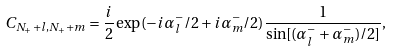Convert formula to latex. <formula><loc_0><loc_0><loc_500><loc_500>C _ { N _ { + } + l , N _ { + } + m } = \frac { i } { 2 } \exp ( - i \alpha _ { l } ^ { - } / 2 + i \alpha _ { m } ^ { - } / 2 ) \frac { 1 } { \sin [ ( \alpha _ { l } ^ { - } + \alpha _ { m } ^ { - } ) / 2 ] } ,</formula> 